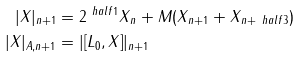Convert formula to latex. <formula><loc_0><loc_0><loc_500><loc_500>| X | _ { n + 1 } & = 2 ^ { \ h a l f { 1 } } \| X \| _ { n } + M ( \| X \| _ { n + 1 } + \| X \| _ { n + \ h a l f { 3 } } ) \\ | X | _ { A , n + 1 } & = | [ L _ { 0 } , X ] | _ { n + 1 }</formula> 